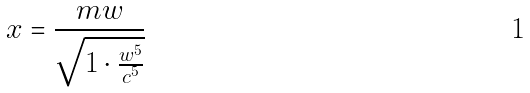<formula> <loc_0><loc_0><loc_500><loc_500>x = \frac { m w } { \sqrt { 1 \cdot \frac { w ^ { 5 } } { c ^ { 5 } } } }</formula> 